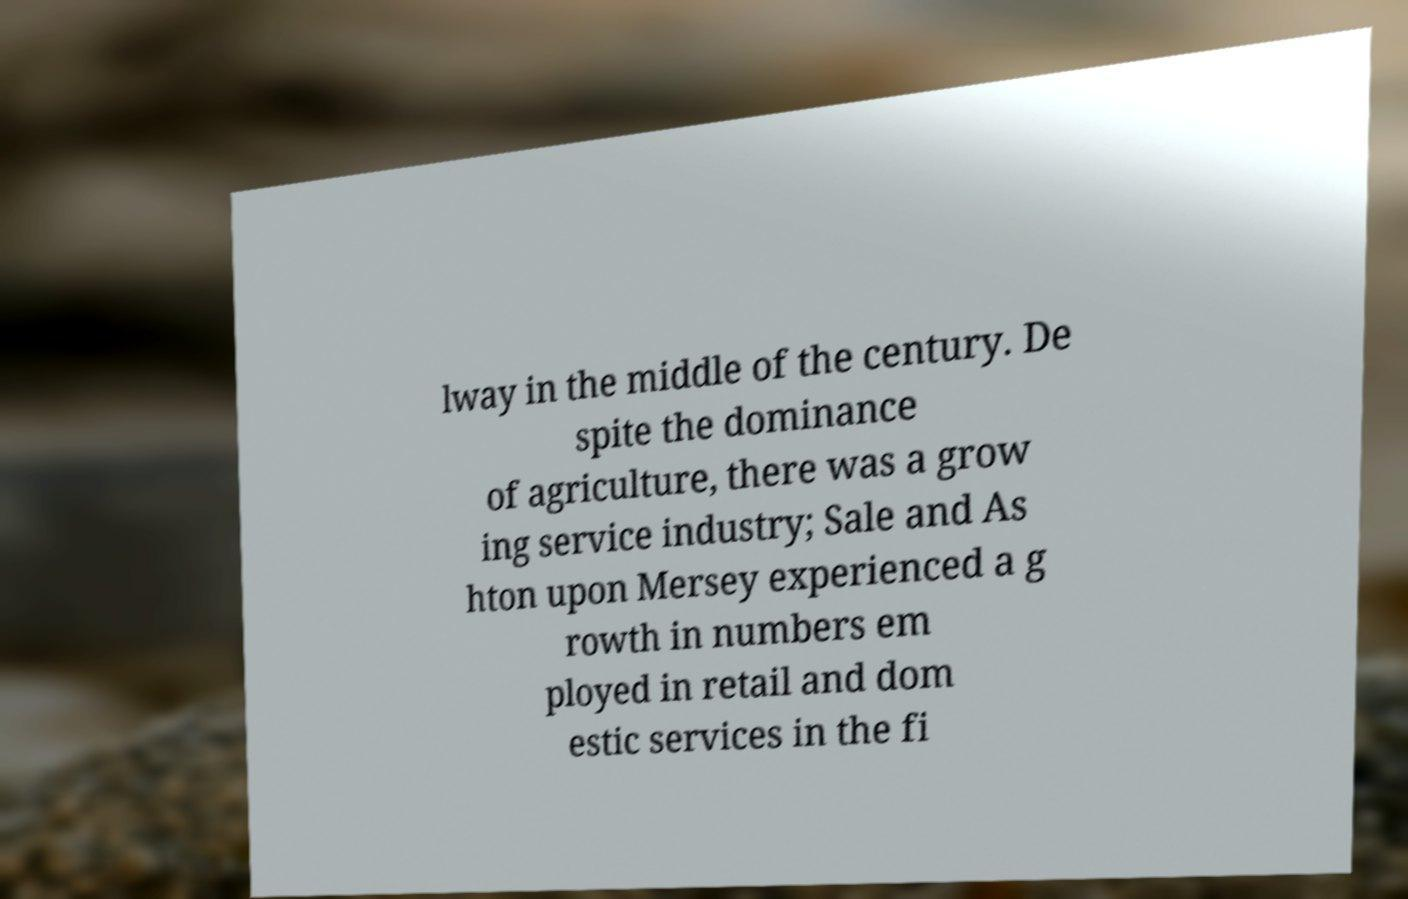What messages or text are displayed in this image? I need them in a readable, typed format. lway in the middle of the century. De spite the dominance of agriculture, there was a grow ing service industry; Sale and As hton upon Mersey experienced a g rowth in numbers em ployed in retail and dom estic services in the fi 